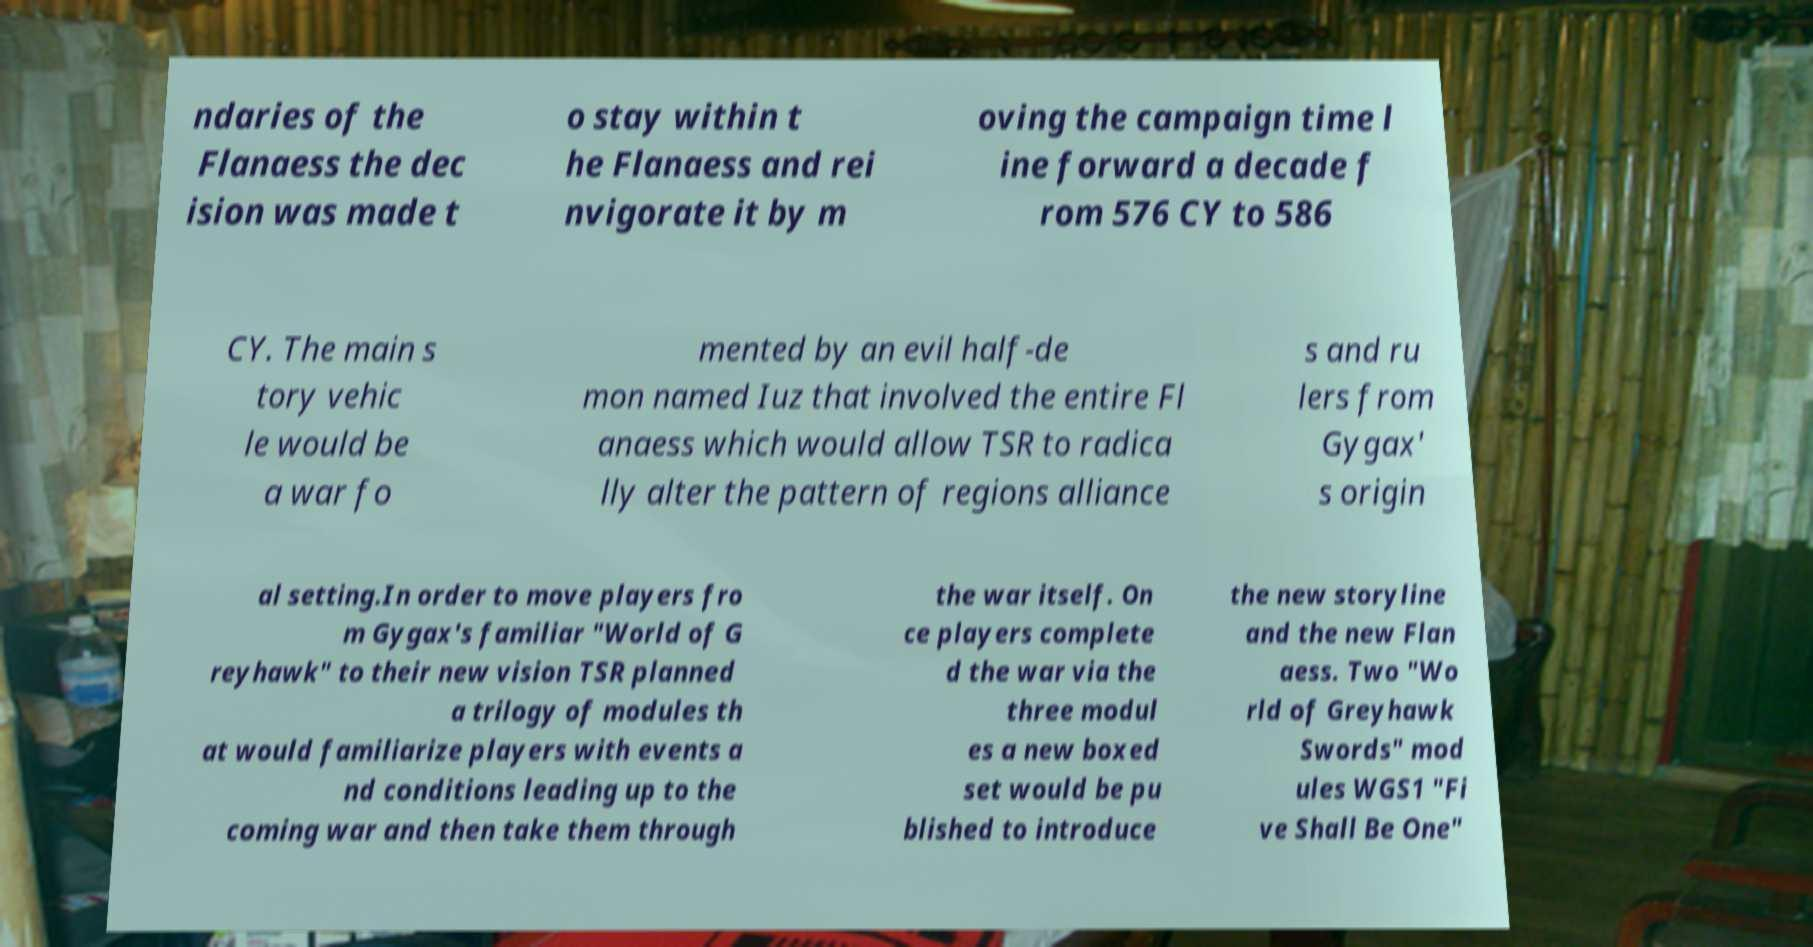I need the written content from this picture converted into text. Can you do that? ndaries of the Flanaess the dec ision was made t o stay within t he Flanaess and rei nvigorate it by m oving the campaign time l ine forward a decade f rom 576 CY to 586 CY. The main s tory vehic le would be a war fo mented by an evil half-de mon named Iuz that involved the entire Fl anaess which would allow TSR to radica lly alter the pattern of regions alliance s and ru lers from Gygax' s origin al setting.In order to move players fro m Gygax's familiar "World of G reyhawk" to their new vision TSR planned a trilogy of modules th at would familiarize players with events a nd conditions leading up to the coming war and then take them through the war itself. On ce players complete d the war via the three modul es a new boxed set would be pu blished to introduce the new storyline and the new Flan aess. Two "Wo rld of Greyhawk Swords" mod ules WGS1 "Fi ve Shall Be One" 